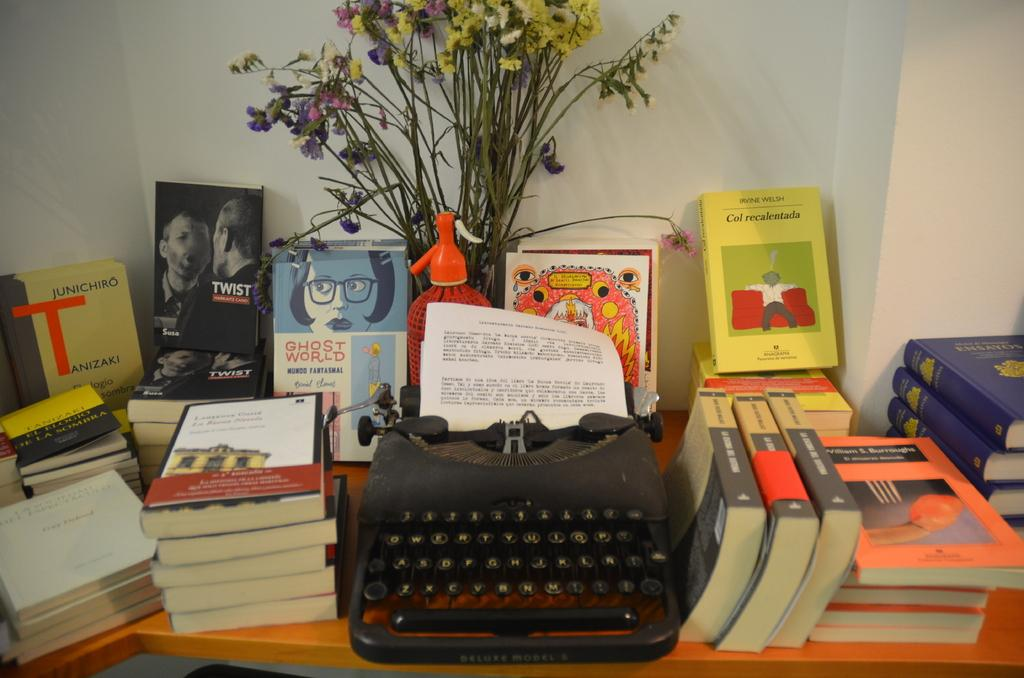What objects are on the table in the image? There are many books and a typewriter on the table. What is the typewriter doing in the image? The typewriter has a paper in it, suggesting that it is being used for writing or typing. What can be seen in the background of the image? There is a wall and a flower vase with flowers in the background of the image. What type of tin can be seen in the image? There is no tin present in the image. How many boys are visible in the image? There are no boys visible in the image. 